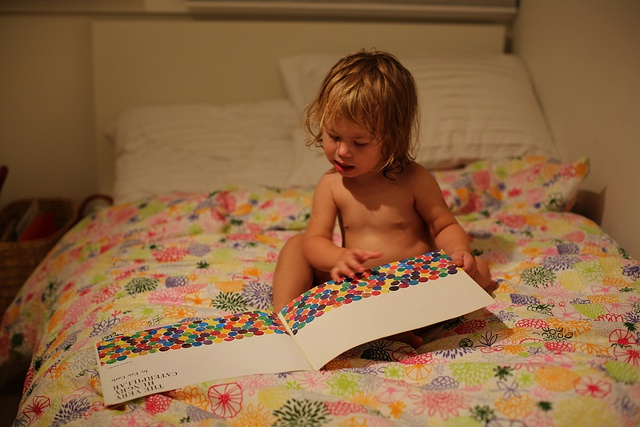Describe the objects in this image and their specific colors. I can see bed in black, gray, tan, and brown tones, people in black, maroon, and brown tones, and book in black, tan, and maroon tones in this image. 